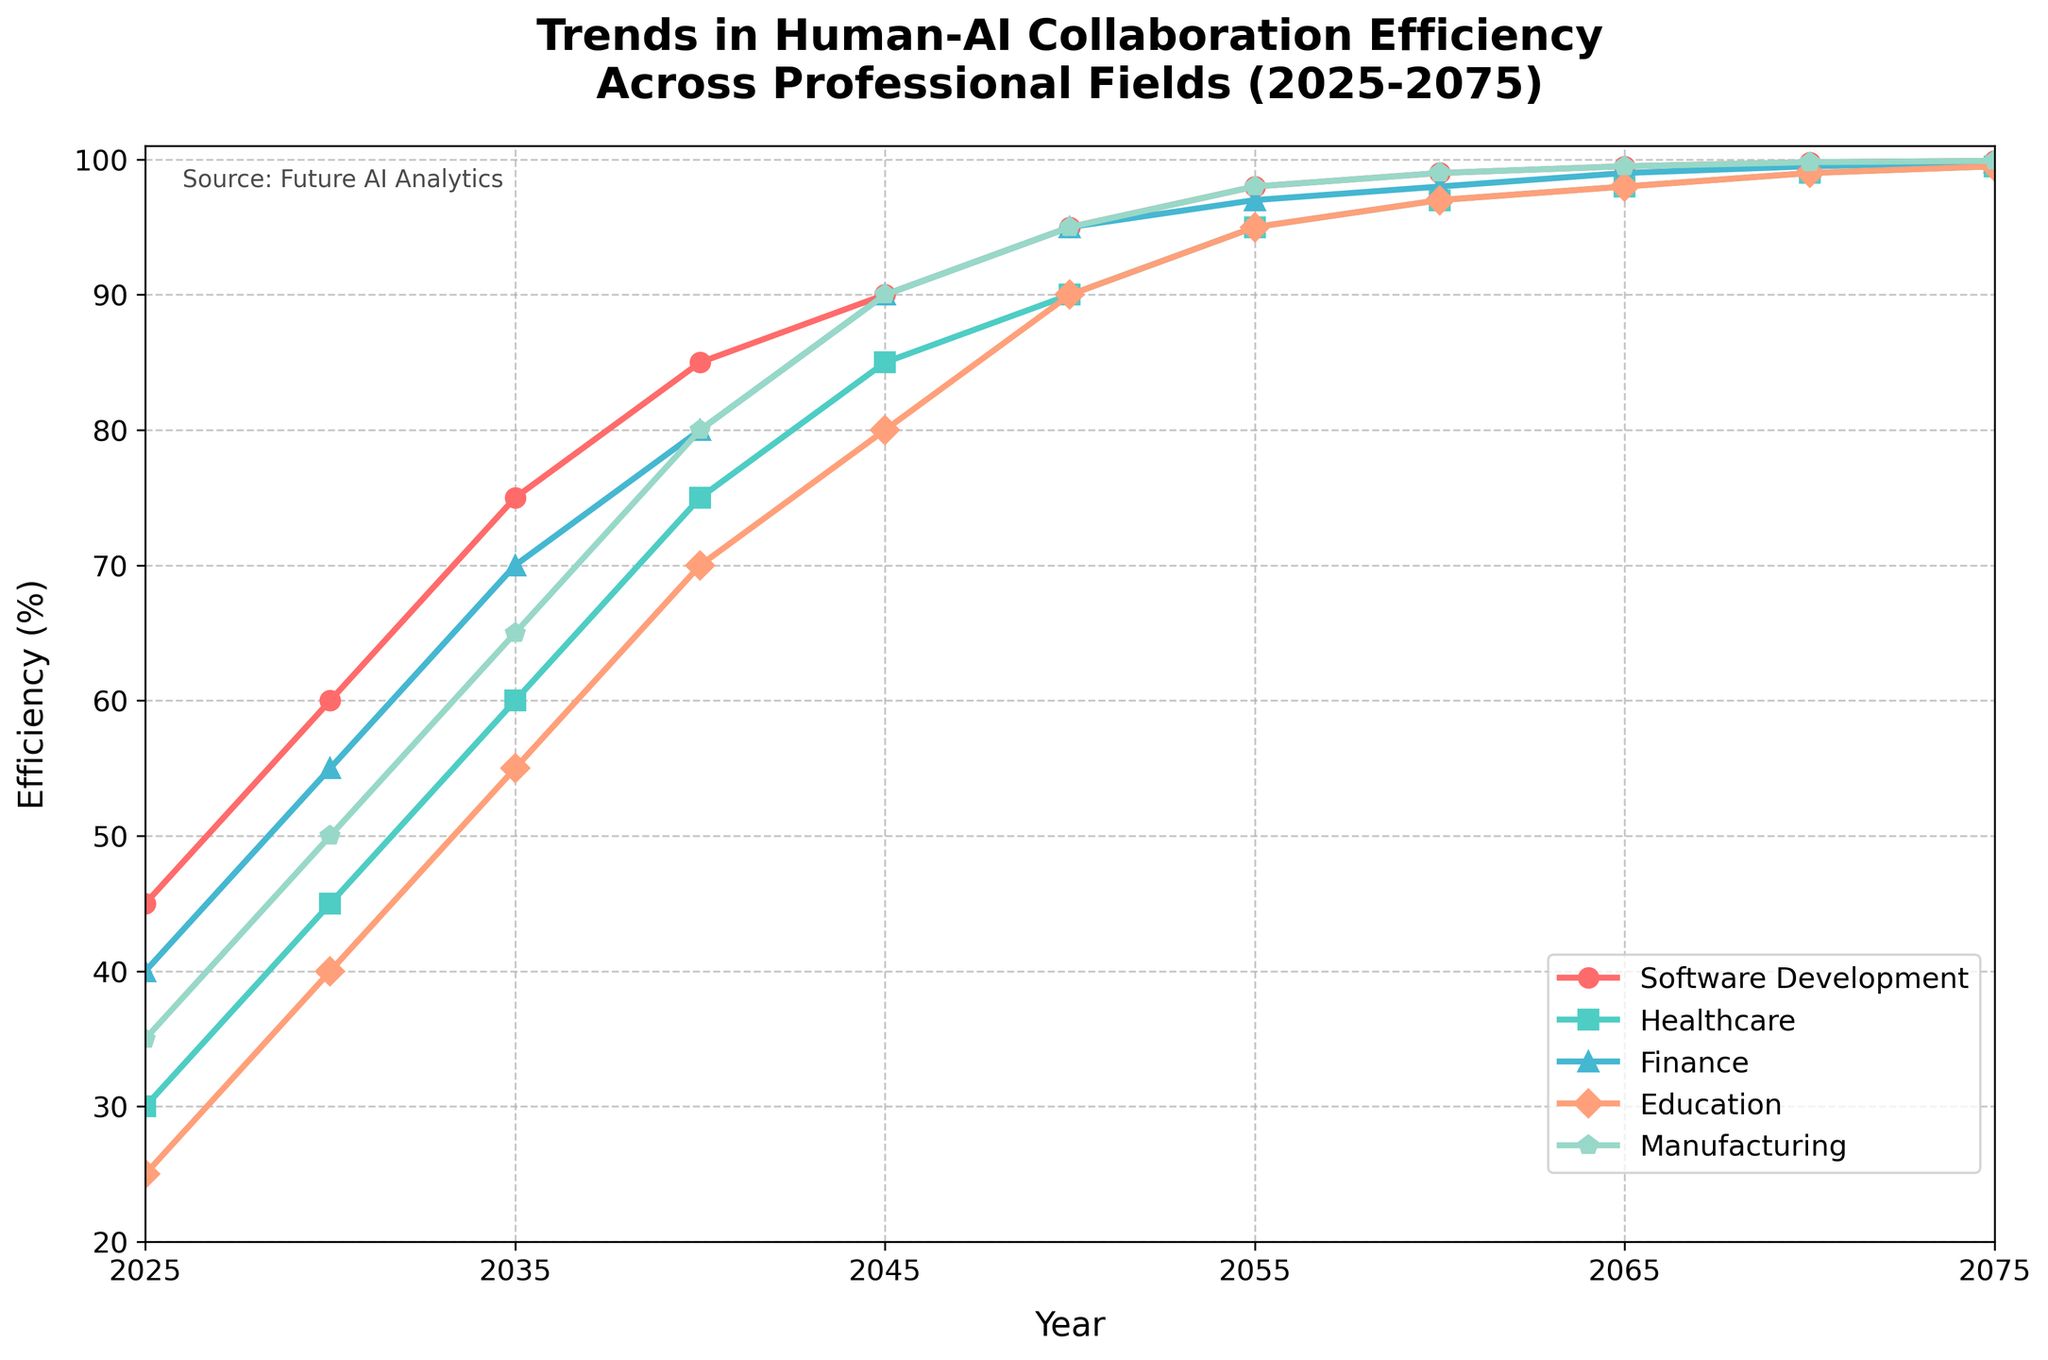What year does healthcare reach an efficiency of 90%? Looking at the healthcare line, the efficiency reaches 90% in the year 2050.
Answer: 2050 Which field shows the fastest increase in efficiency from 2025 to 2075? Comparing the slopes of the lines from 2025 to 2075, healthcare has the steepest slope, indicating the fastest increase in efficiency.
Answer: Healthcare By how much does the efficiency in education increase from 2025 to 2050? In 2025, education has an efficiency of 25%, and in 2050, it reaches 90%. The increase is 90% - 25% = 65%.
Answer: 65% Which field reaches 99% efficiency first? Observing the chart, software development reaches 99% efficiency first in the year 2060.
Answer: Software Development What is the difference in efficiency between healthcare and finance in 2040? In 2040, healthcare has an efficiency of 75% while finance is at 80%. The difference is 80% - 75% = 5%.
Answer: 5% Between which years does manufacturing see the largest increase in efficiency? Manufacturing efficiency increased most significantly from 2025 to 2030, from 35% to 50%, equating to an increase of 15%.
Answer: 2025 to 2030 What is the average efficiency of software development and finance in 2075? In 2075, software development has an efficiency of 99.9% and finance has 99.8%. The average efficiency is (99.9% + 99.8%) / 2 = 99.85%.
Answer: 99.85% Which field crosses the 95% efficiency mark last and in which year? Observing the efficiency trends, education reaches the 95% mark last in the year 2055.
Answer: Education, 2055 